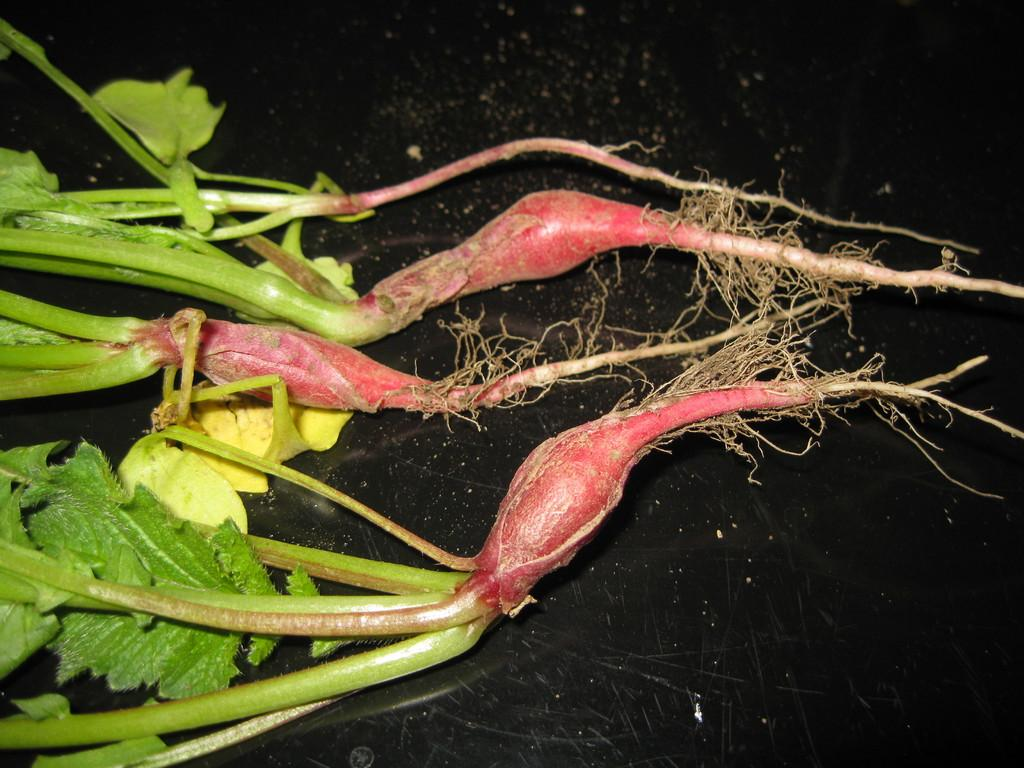What type of plants can be seen in the image? There are vegetable plants in the image. What is the color of the surface beneath the plants? The surface beneath the plants is black in color. What type of disease is affecting the plants in the image? There is no indication of any disease affecting the plants in the image. 